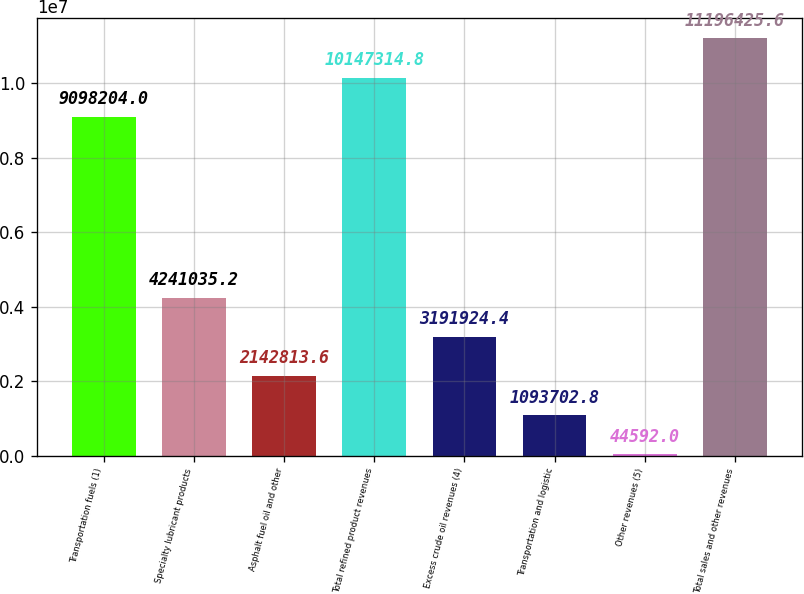Convert chart. <chart><loc_0><loc_0><loc_500><loc_500><bar_chart><fcel>Transportation fuels (1)<fcel>Specialty lubricant products<fcel>Asphalt fuel oil and other<fcel>Total refined product revenues<fcel>Excess crude oil revenues (4)<fcel>Transportation and logistic<fcel>Other revenues (5)<fcel>Total sales and other revenues<nl><fcel>9.0982e+06<fcel>4.24104e+06<fcel>2.14281e+06<fcel>1.01473e+07<fcel>3.19192e+06<fcel>1.0937e+06<fcel>44592<fcel>1.11964e+07<nl></chart> 